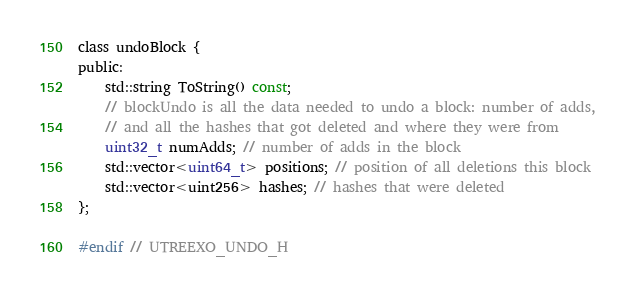<code> <loc_0><loc_0><loc_500><loc_500><_C_>class undoBlock {
public:
    std::string ToString() const;
    // blockUndo is all the data needed to undo a block: number of adds,
    // and all the hashes that got deleted and where they were from
    uint32_t numAdds; // number of adds in the block
    std::vector<uint64_t> positions; // position of all deletions this block
    std::vector<uint256> hashes; // hashes that were deleted
};

#endif // UTREEXO_UNDO_H
</code> 